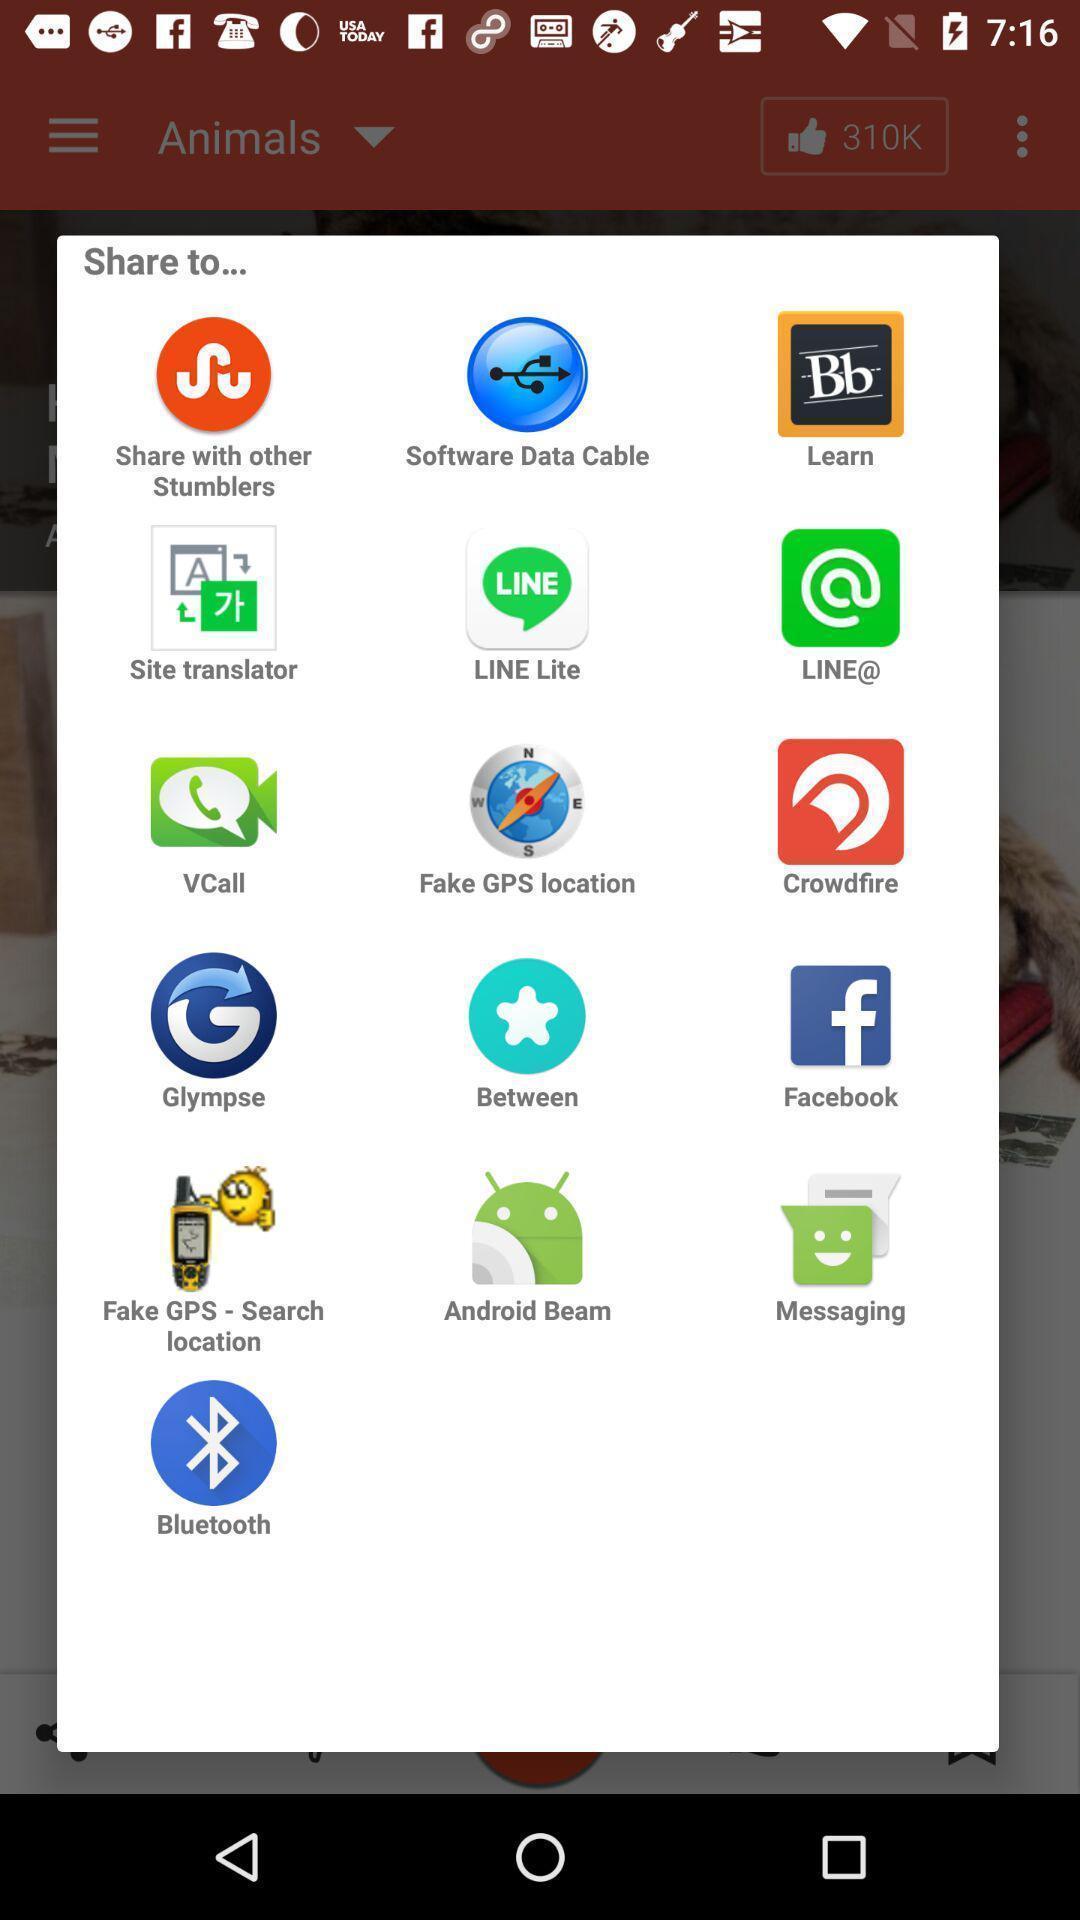Describe the visual elements of this screenshot. Pop-up with different options for sharing a link. 